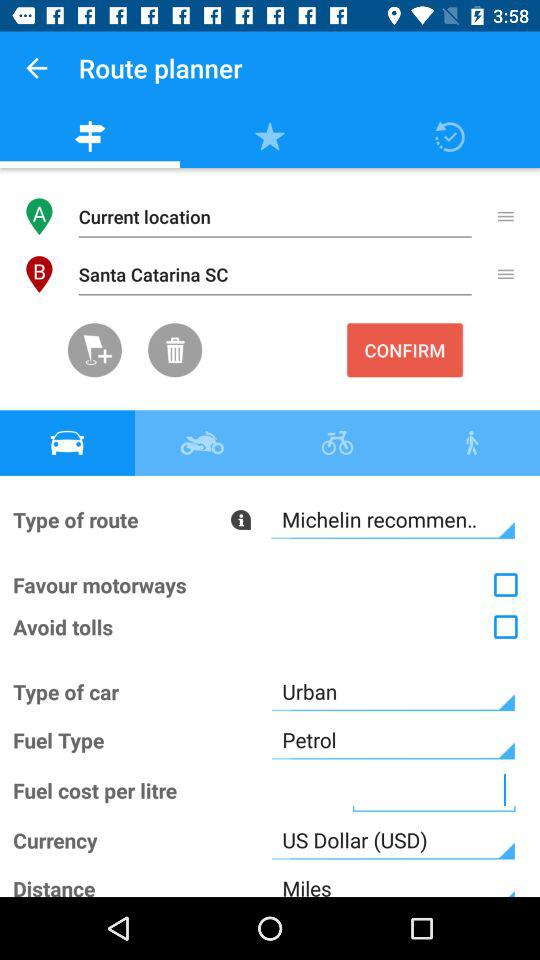What is the mentioned location? The mentioned location is Santa Catarina SC. 